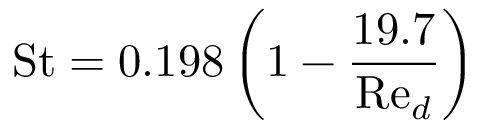<formula> <loc_0><loc_0><loc_500><loc_500>{ S t } = 0 . 1 9 8 \left ( 1 - { \frac { 1 9 . 7 } { { R e } _ { d } } } \right )</formula> 